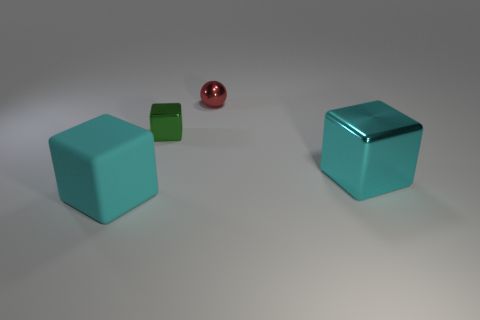How many cyan cubes must be subtracted to get 1 cyan cubes? 1 Subtract all rubber cubes. How many cubes are left? 2 Subtract all green cubes. How many cubes are left? 2 Subtract 2 cubes. How many cubes are left? 1 Add 2 tiny green metallic cubes. How many objects exist? 6 Subtract all balls. How many objects are left? 3 Add 3 tiny gray balls. How many tiny gray balls exist? 3 Subtract 0 gray balls. How many objects are left? 4 Subtract all gray blocks. Subtract all red spheres. How many blocks are left? 3 Subtract all brown balls. How many cyan blocks are left? 2 